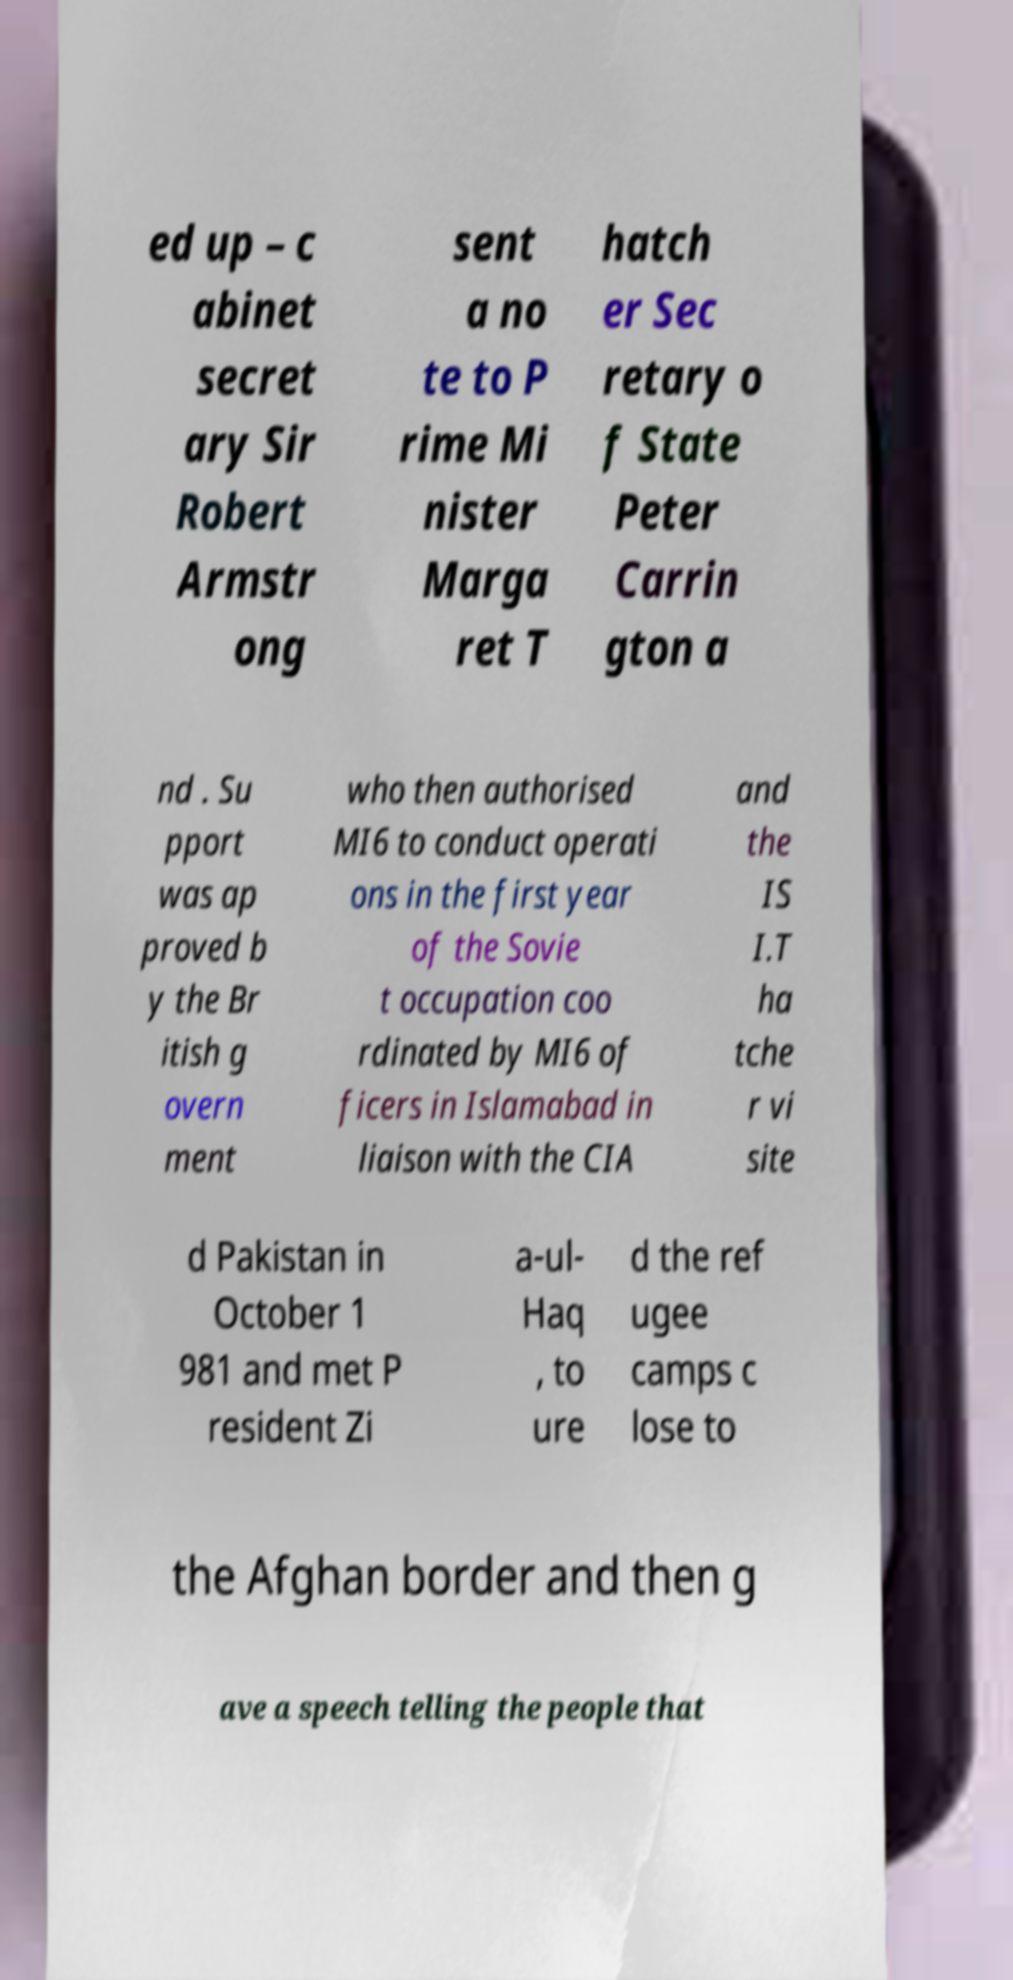Please identify and transcribe the text found in this image. ed up – c abinet secret ary Sir Robert Armstr ong sent a no te to P rime Mi nister Marga ret T hatch er Sec retary o f State Peter Carrin gton a nd . Su pport was ap proved b y the Br itish g overn ment who then authorised MI6 to conduct operati ons in the first year of the Sovie t occupation coo rdinated by MI6 of ficers in Islamabad in liaison with the CIA and the IS I.T ha tche r vi site d Pakistan in October 1 981 and met P resident Zi a-ul- Haq , to ure d the ref ugee camps c lose to the Afghan border and then g ave a speech telling the people that 